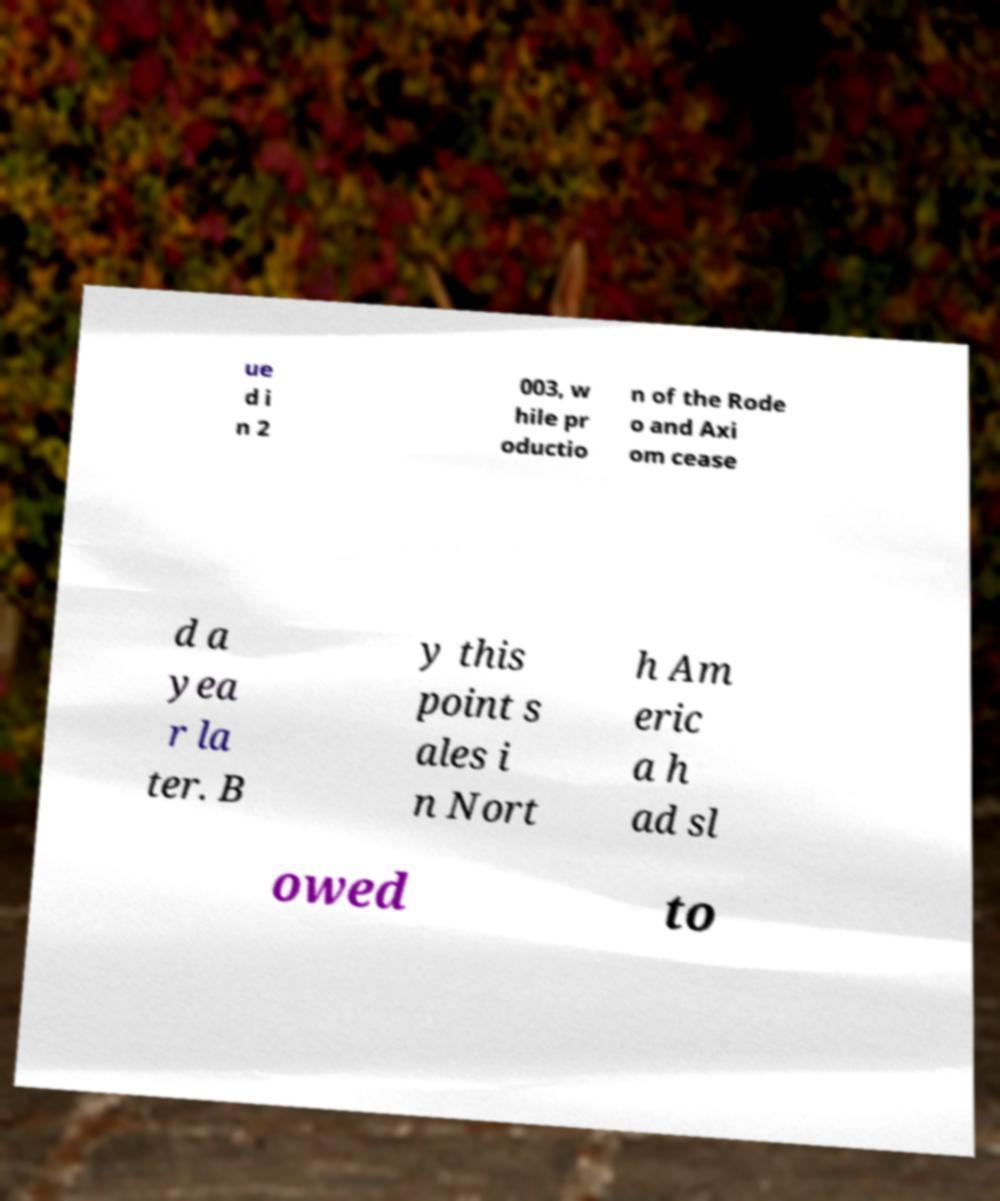Can you read and provide the text displayed in the image?This photo seems to have some interesting text. Can you extract and type it out for me? ue d i n 2 003, w hile pr oductio n of the Rode o and Axi om cease d a yea r la ter. B y this point s ales i n Nort h Am eric a h ad sl owed to 